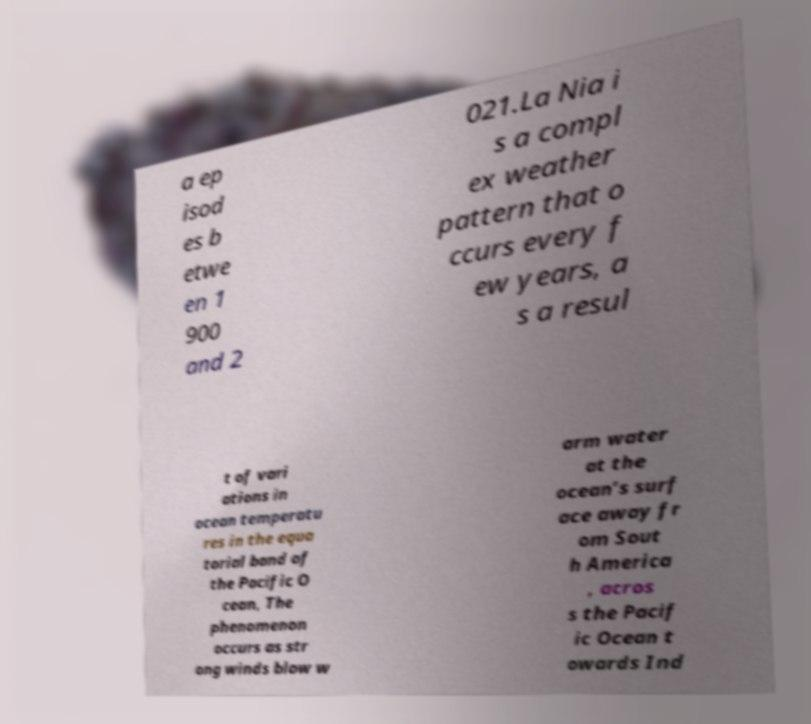For documentation purposes, I need the text within this image transcribed. Could you provide that? a ep isod es b etwe en 1 900 and 2 021.La Nia i s a compl ex weather pattern that o ccurs every f ew years, a s a resul t of vari ations in ocean temperatu res in the equa torial band of the Pacific O cean, The phenomenon occurs as str ong winds blow w arm water at the ocean’s surf ace away fr om Sout h America , acros s the Pacif ic Ocean t owards Ind 